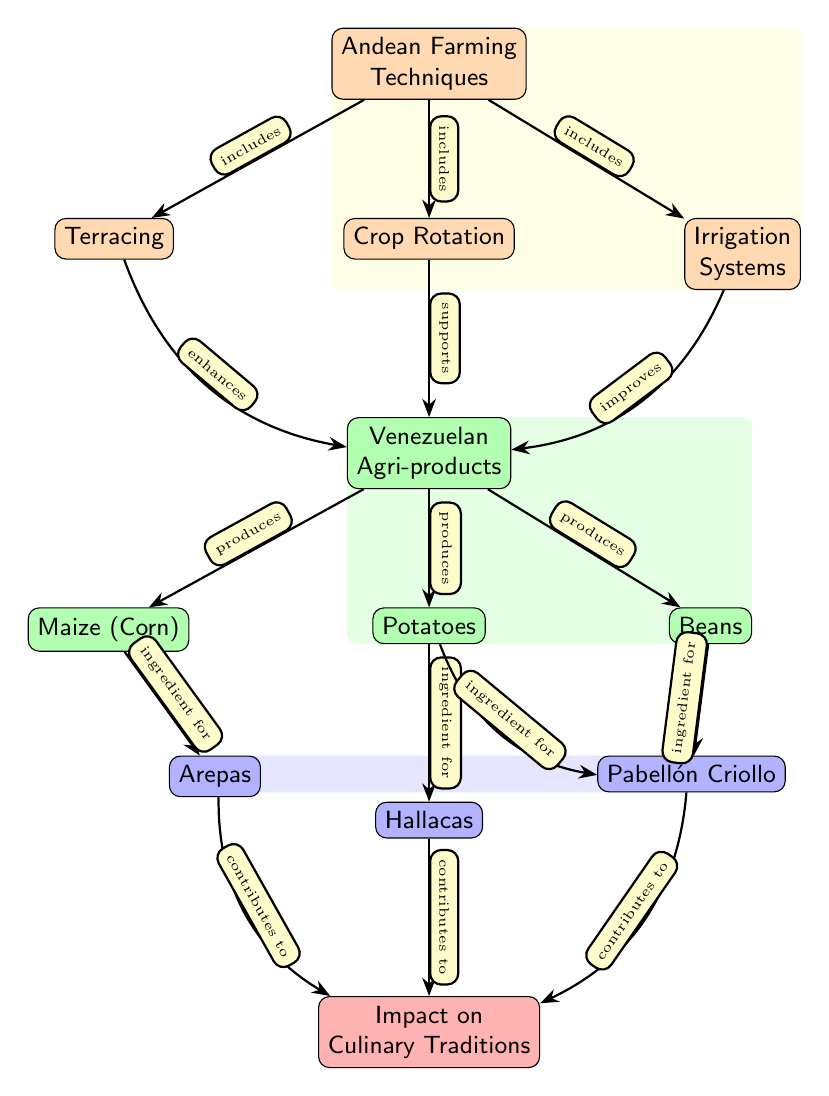What are the Andean farming techniques mentioned in the diagram? The diagram lists three techniques: Terracing, Crop Rotation, and Irrigation Systems that are all included under Andean Farming Techniques.
Answer: Terracing, Crop Rotation, Irrigation Systems How many Venezuelan agri-products are listed in the diagram? The diagram shows three Venezuelan agri-products: Maize (Corn), Potatoes, and Beans, leading to a total count of three listed products.
Answer: 3 Which dish is made using both potatoes and beans? The diagram indicates that Pabellón Criollo is made using both ingredients, as it connects to both Potatoes and Beans.
Answer: Pabellón Criollo What impact do the described techniques have on culinary traditions? The impact of Andean farming techniques in the diagram directly influences Venezuelan culinary traditions, as shown in the last node that connects all the dishes named.
Answer: Impact on Culinary Traditions Which technique is shown as enhancing Venezuelan agri-products? The diagram clearly shows that the technique of Terracing enhances Venezuelan agri-products, as indicated by the arrow connecting them.
Answer: Terracing How many dishes are listed in the diagram as contributions to culinary traditions? The diagram presents three dishes: Arepas, Hallacas, and Pabellón Criollo, showing that a total of three dishes contribute to culinary traditions.
Answer: 3 Which Venezuelan agri-product is not directly connected to a farming technique in the diagram? Upon reviewing the diagram, the Maize (Corn) does not have a direct connection to the farming techniques; it is only directly connected to the dish Arepas.
Answer: Maize (Corn) Which farming technique supports the production of Venezuelan agri-products? According to the diagram, the technique of Crop Rotation supports the production of Venezuelan agri-products, as evidenced by its direct connection to the agri-products node.
Answer: Crop Rotation What are the ingredients for the dish Hallacas according to the diagram? The diagram indicates that Hallacas is made primarily using Potatoes, showing its connection to the product node for potatoes.
Answer: Potatoes 